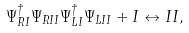<formula> <loc_0><loc_0><loc_500><loc_500>\Psi _ { R I } ^ { \dagger } \Psi _ { R I I } \Psi _ { L I } ^ { \dagger } \Psi _ { L I I } + I \leftrightarrow I I ,</formula> 